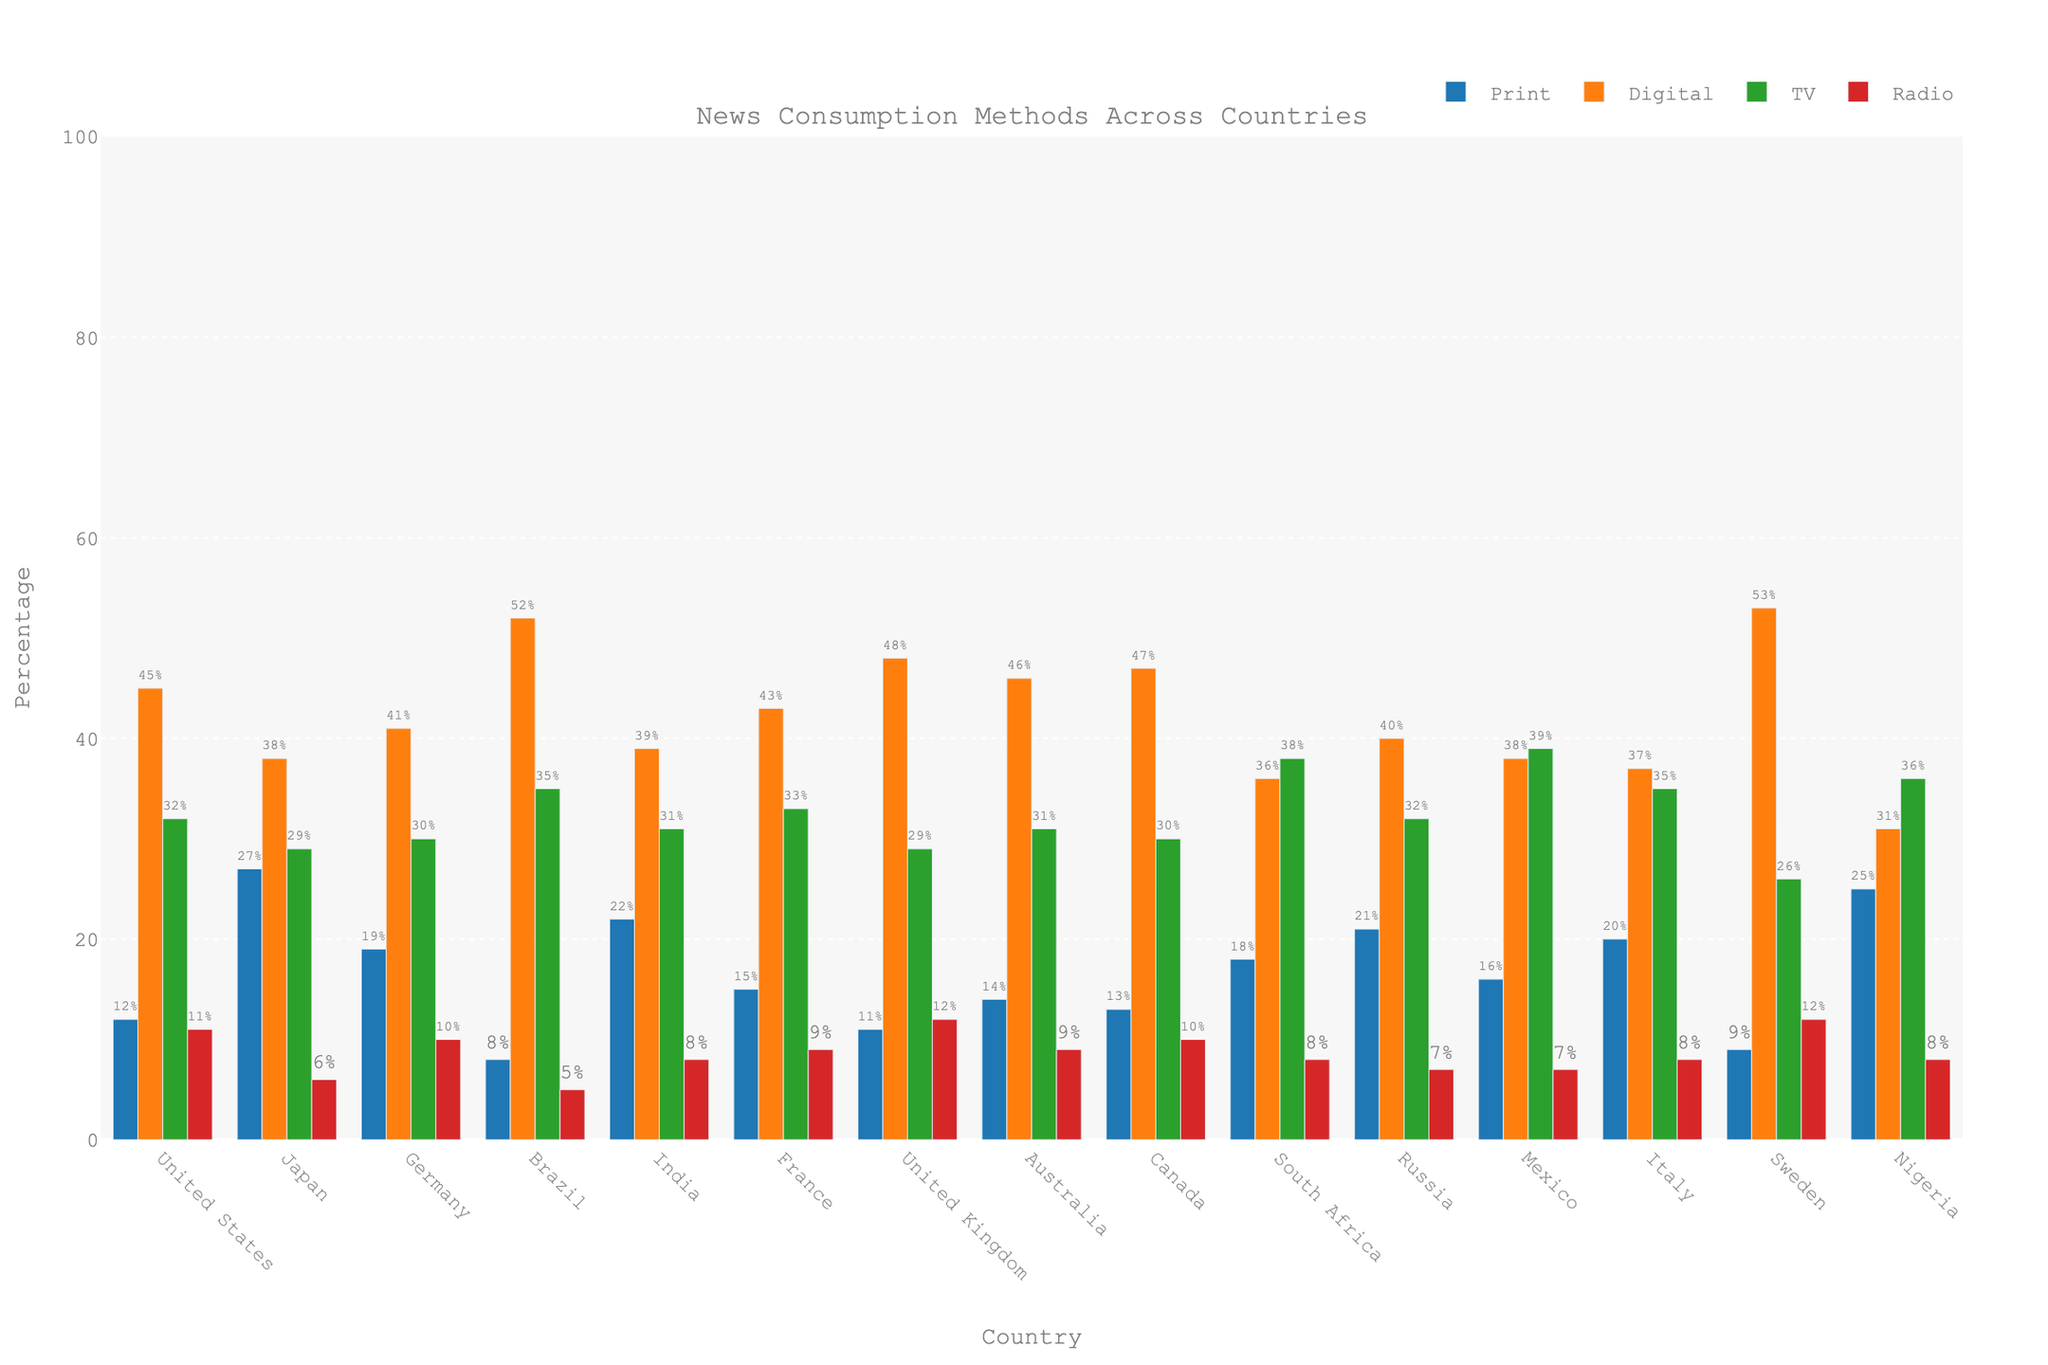Which country has the highest percentage of digital news consumption? Referring to the bar heights for digital news consumption across all countries, Sweden has the tallest bar, indicating the highest percentage.
Answer: Sweden What is the total percentage of print news consumption in Japan and Germany combined? Adding the print percentages of Japan (27%) and Germany (19%), we get 27 + 19 = 46%.
Answer: 46% Compare the TV news consumption between Brazil and South Africa. Which country has a higher percentage? By looking at the heights of the bars for TV news consumption in Brazil and South Africa, South Africa has a higher percentage (38%) compared to Brazil (35%).
Answer: South Africa Which countries have exactly 10% radio news consumption? The radio consumption bar heights show that Germany and Canada both have bars reaching the 10% mark.
Answer: Germany, Canada What is the average percentage of digital news consumption across all the countries shown? Summing the digital percentages for all countries and dividing by 15 (total number of countries) gives the average: (45 + 38 + 41 + 52 + 39 + 43 + 48 + 46 + 47 + 36 + 40 + 38 + 37 + 53 + 31) / 15 = 41.1%.
Answer: 41.1% Which country has the smallest percentage of radio news consumption? Observing the bar lengths for radio news consumption, Brazil has the smallest bar at 5%.
Answer: Brazil Is the percentage of print news consumption in Nigeria higher or lower than in Japan? Nigeria's print news consumption (25%) is lower compared to Japan's (27%).
Answer: Lower For the United States and Canada, what is the difference in their digital news consumption percentages? Subtracting the digital news consumption in the United States (45%) from Canada (47%) gives 47 - 45 = 2%.
Answer: 2% Which category of news consumption has the highest overall percentage across all countries when combined? Adding all the percentages: Print (12+27+19+8+22+15+11+14+13+18+21+16+20+9+25 = 250), Digital (45+38+41+52+39+43+48+46+47+36+40+38+37+53+31 = 634), TV (32+29+30+35+31+33+29+31+30+38+32+39+35+26+36 = 476), Radio (11+6+10+5+8+9+12+9+10+8+7+7+8+12+8 = 122) and comparing, Digital (634) is the highest overall.
Answer: Digital 